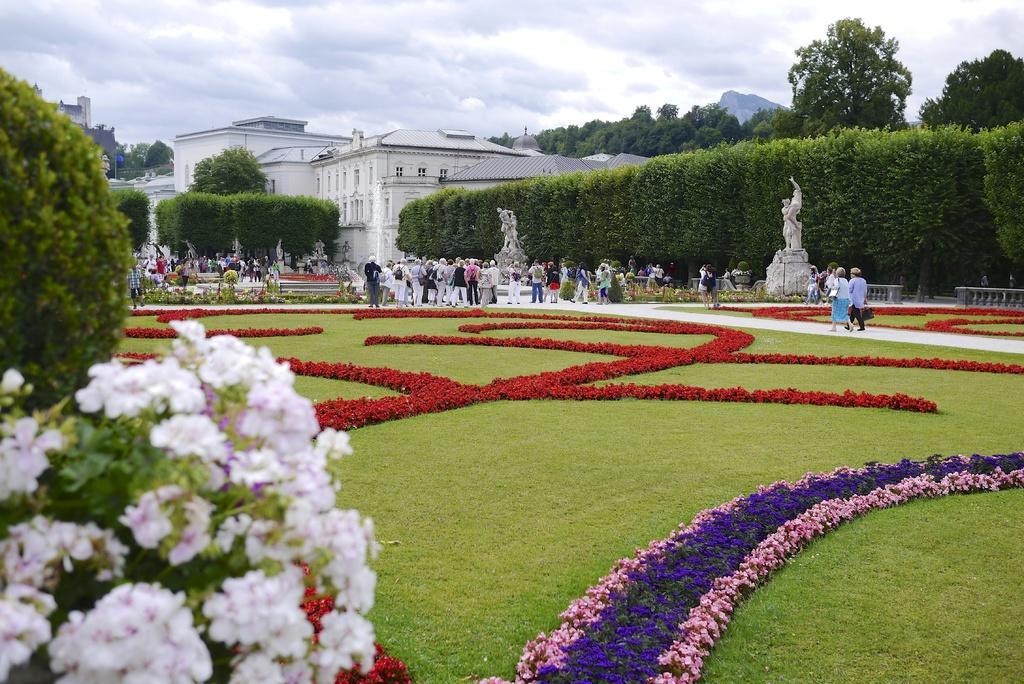Please provide a concise description of this image. In this image at the bottom there is grass, plants and some flowers. On the left side there are some plants and flowers and in the center there are a group of people who are walking and some of them are standing and also we could see some statues. In the background there are some trees, buildings and at the top of the image there is sky. 